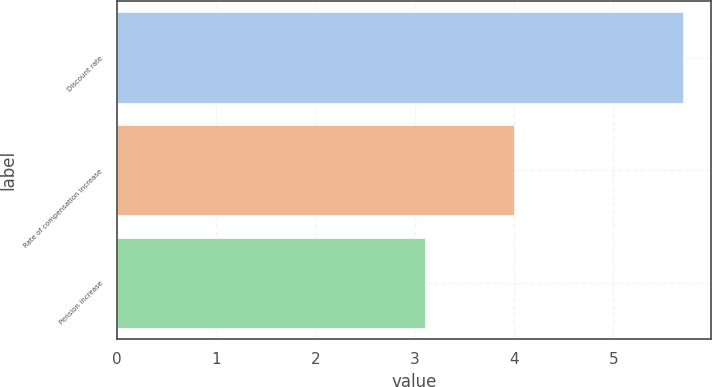Convert chart. <chart><loc_0><loc_0><loc_500><loc_500><bar_chart><fcel>Discount rate<fcel>Rate of compensation increase<fcel>Pension increase<nl><fcel>5.7<fcel>4<fcel>3.1<nl></chart> 